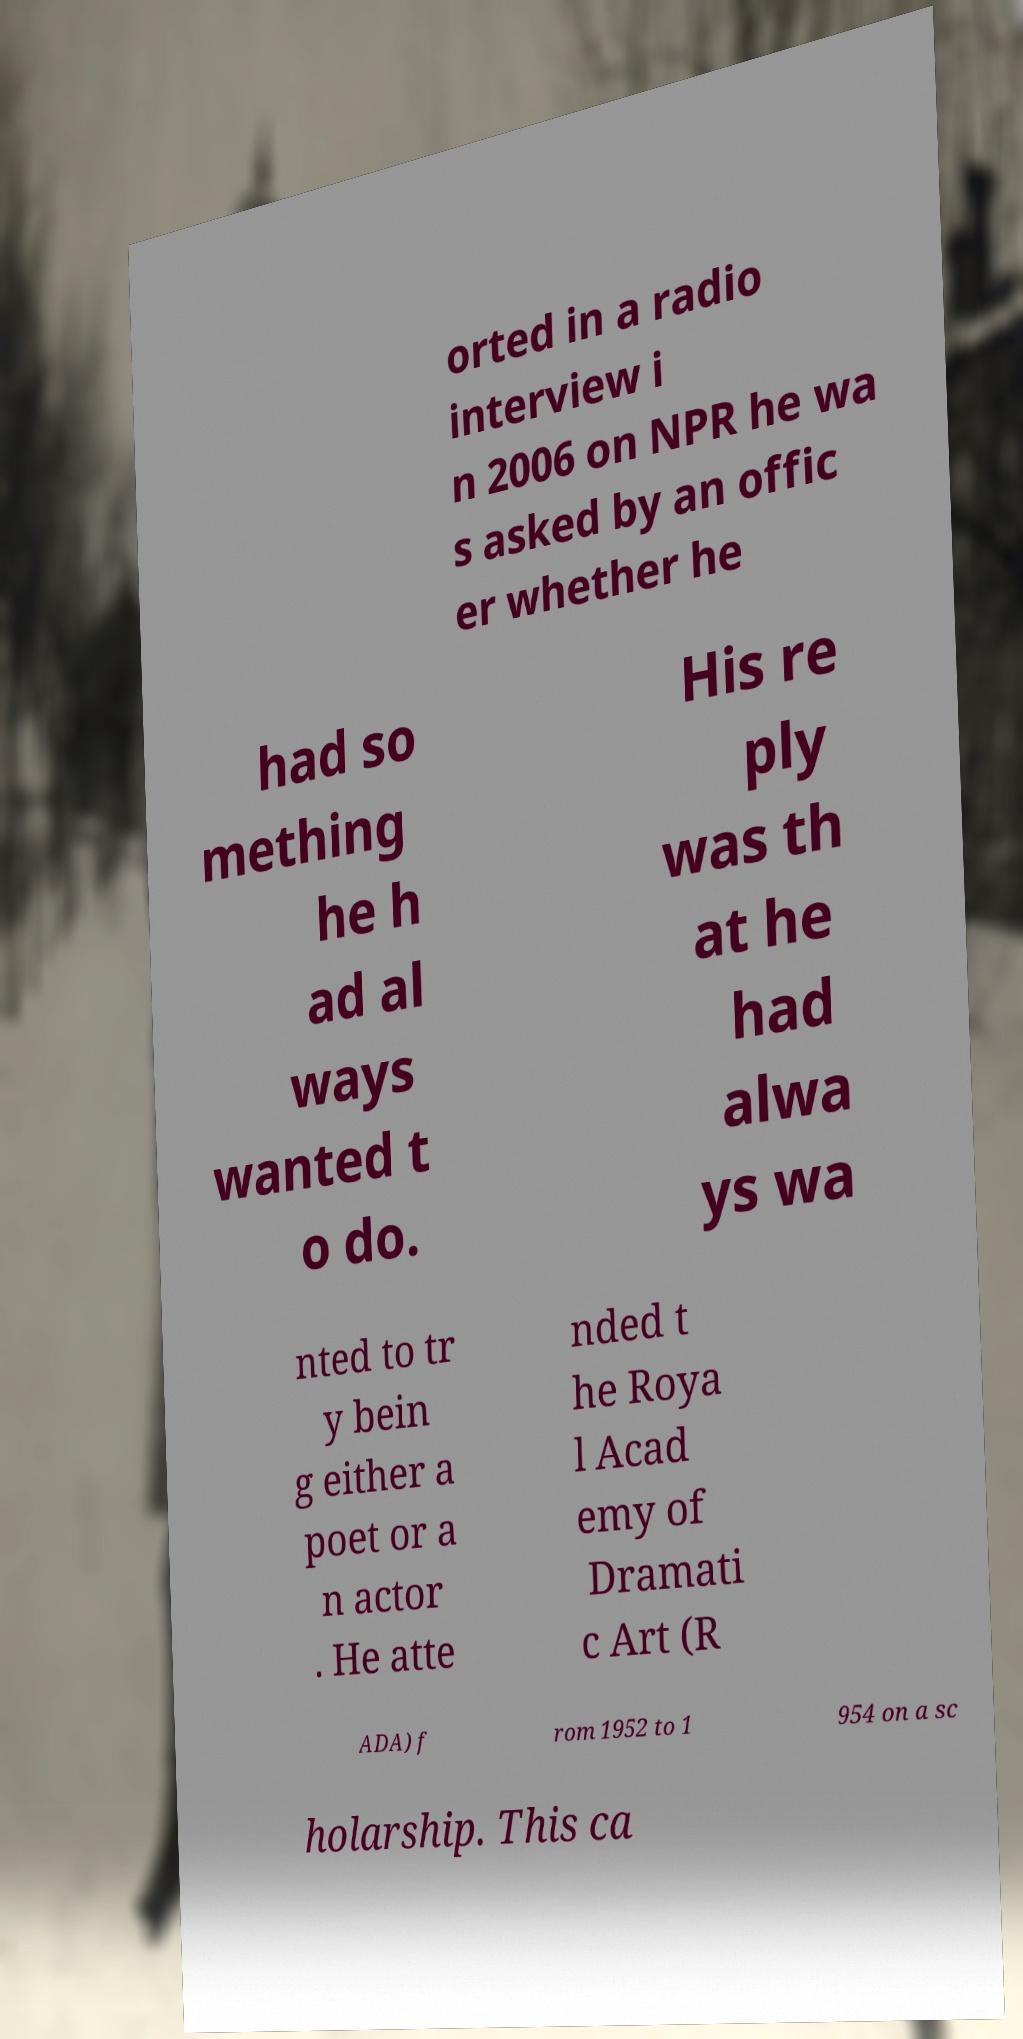Please identify and transcribe the text found in this image. orted in a radio interview i n 2006 on NPR he wa s asked by an offic er whether he had so mething he h ad al ways wanted t o do. His re ply was th at he had alwa ys wa nted to tr y bein g either a poet or a n actor . He atte nded t he Roya l Acad emy of Dramati c Art (R ADA) f rom 1952 to 1 954 on a sc holarship. This ca 